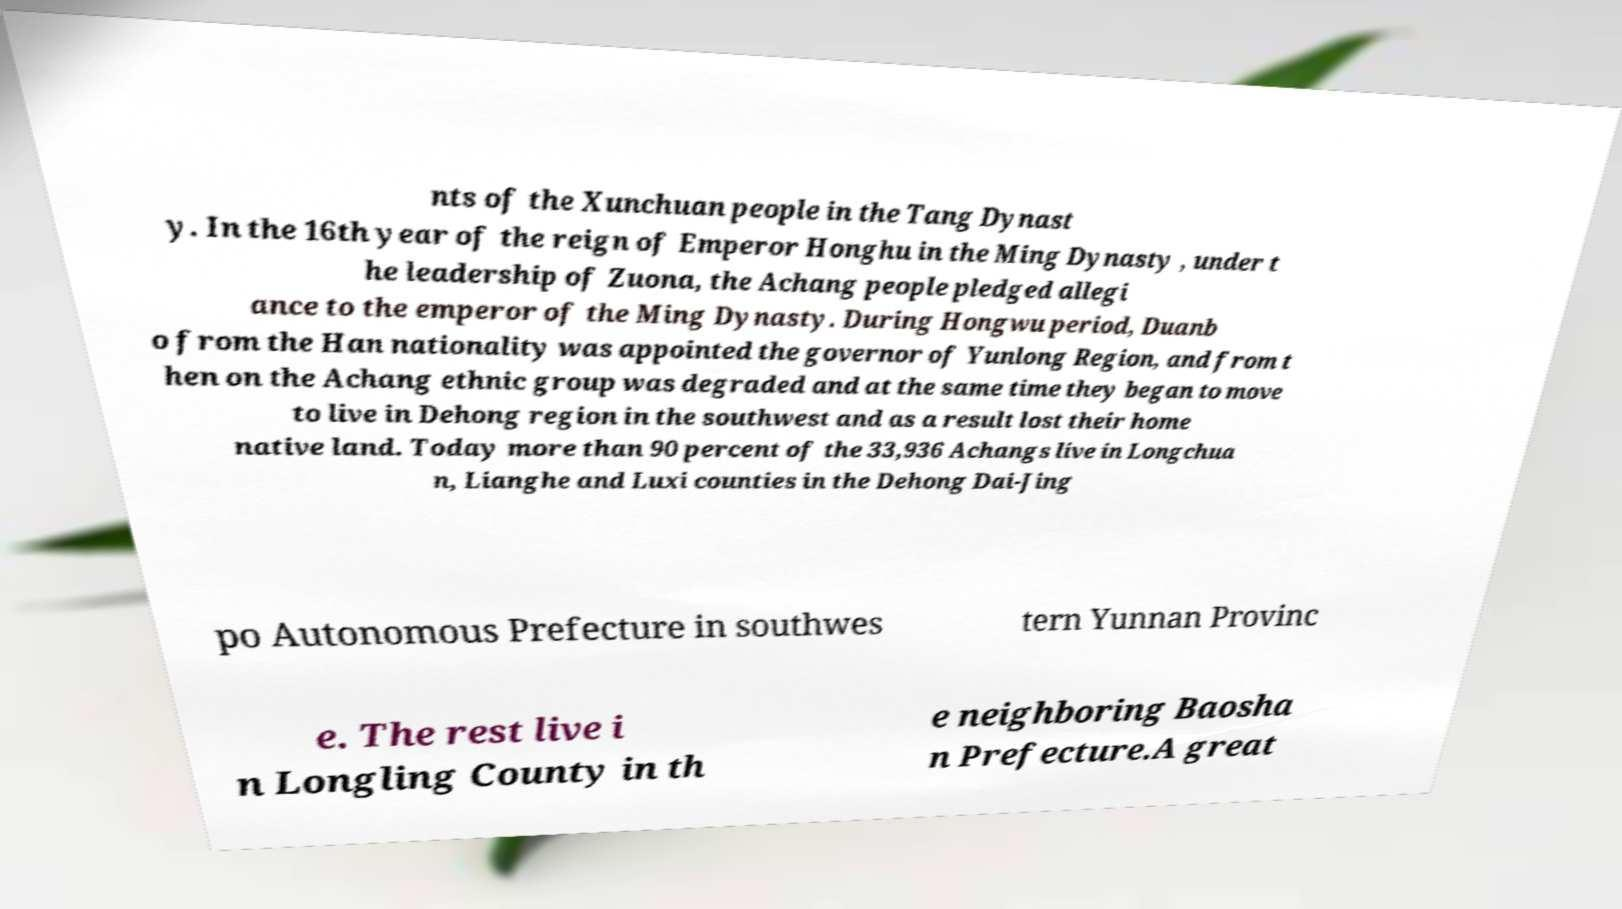For documentation purposes, I need the text within this image transcribed. Could you provide that? nts of the Xunchuan people in the Tang Dynast y. In the 16th year of the reign of Emperor Honghu in the Ming Dynasty , under t he leadership of Zuona, the Achang people pledged allegi ance to the emperor of the Ming Dynasty. During Hongwu period, Duanb o from the Han nationality was appointed the governor of Yunlong Region, and from t hen on the Achang ethnic group was degraded and at the same time they began to move to live in Dehong region in the southwest and as a result lost their home native land. Today more than 90 percent of the 33,936 Achangs live in Longchua n, Lianghe and Luxi counties in the Dehong Dai-Jing po Autonomous Prefecture in southwes tern Yunnan Provinc e. The rest live i n Longling County in th e neighboring Baosha n Prefecture.A great 